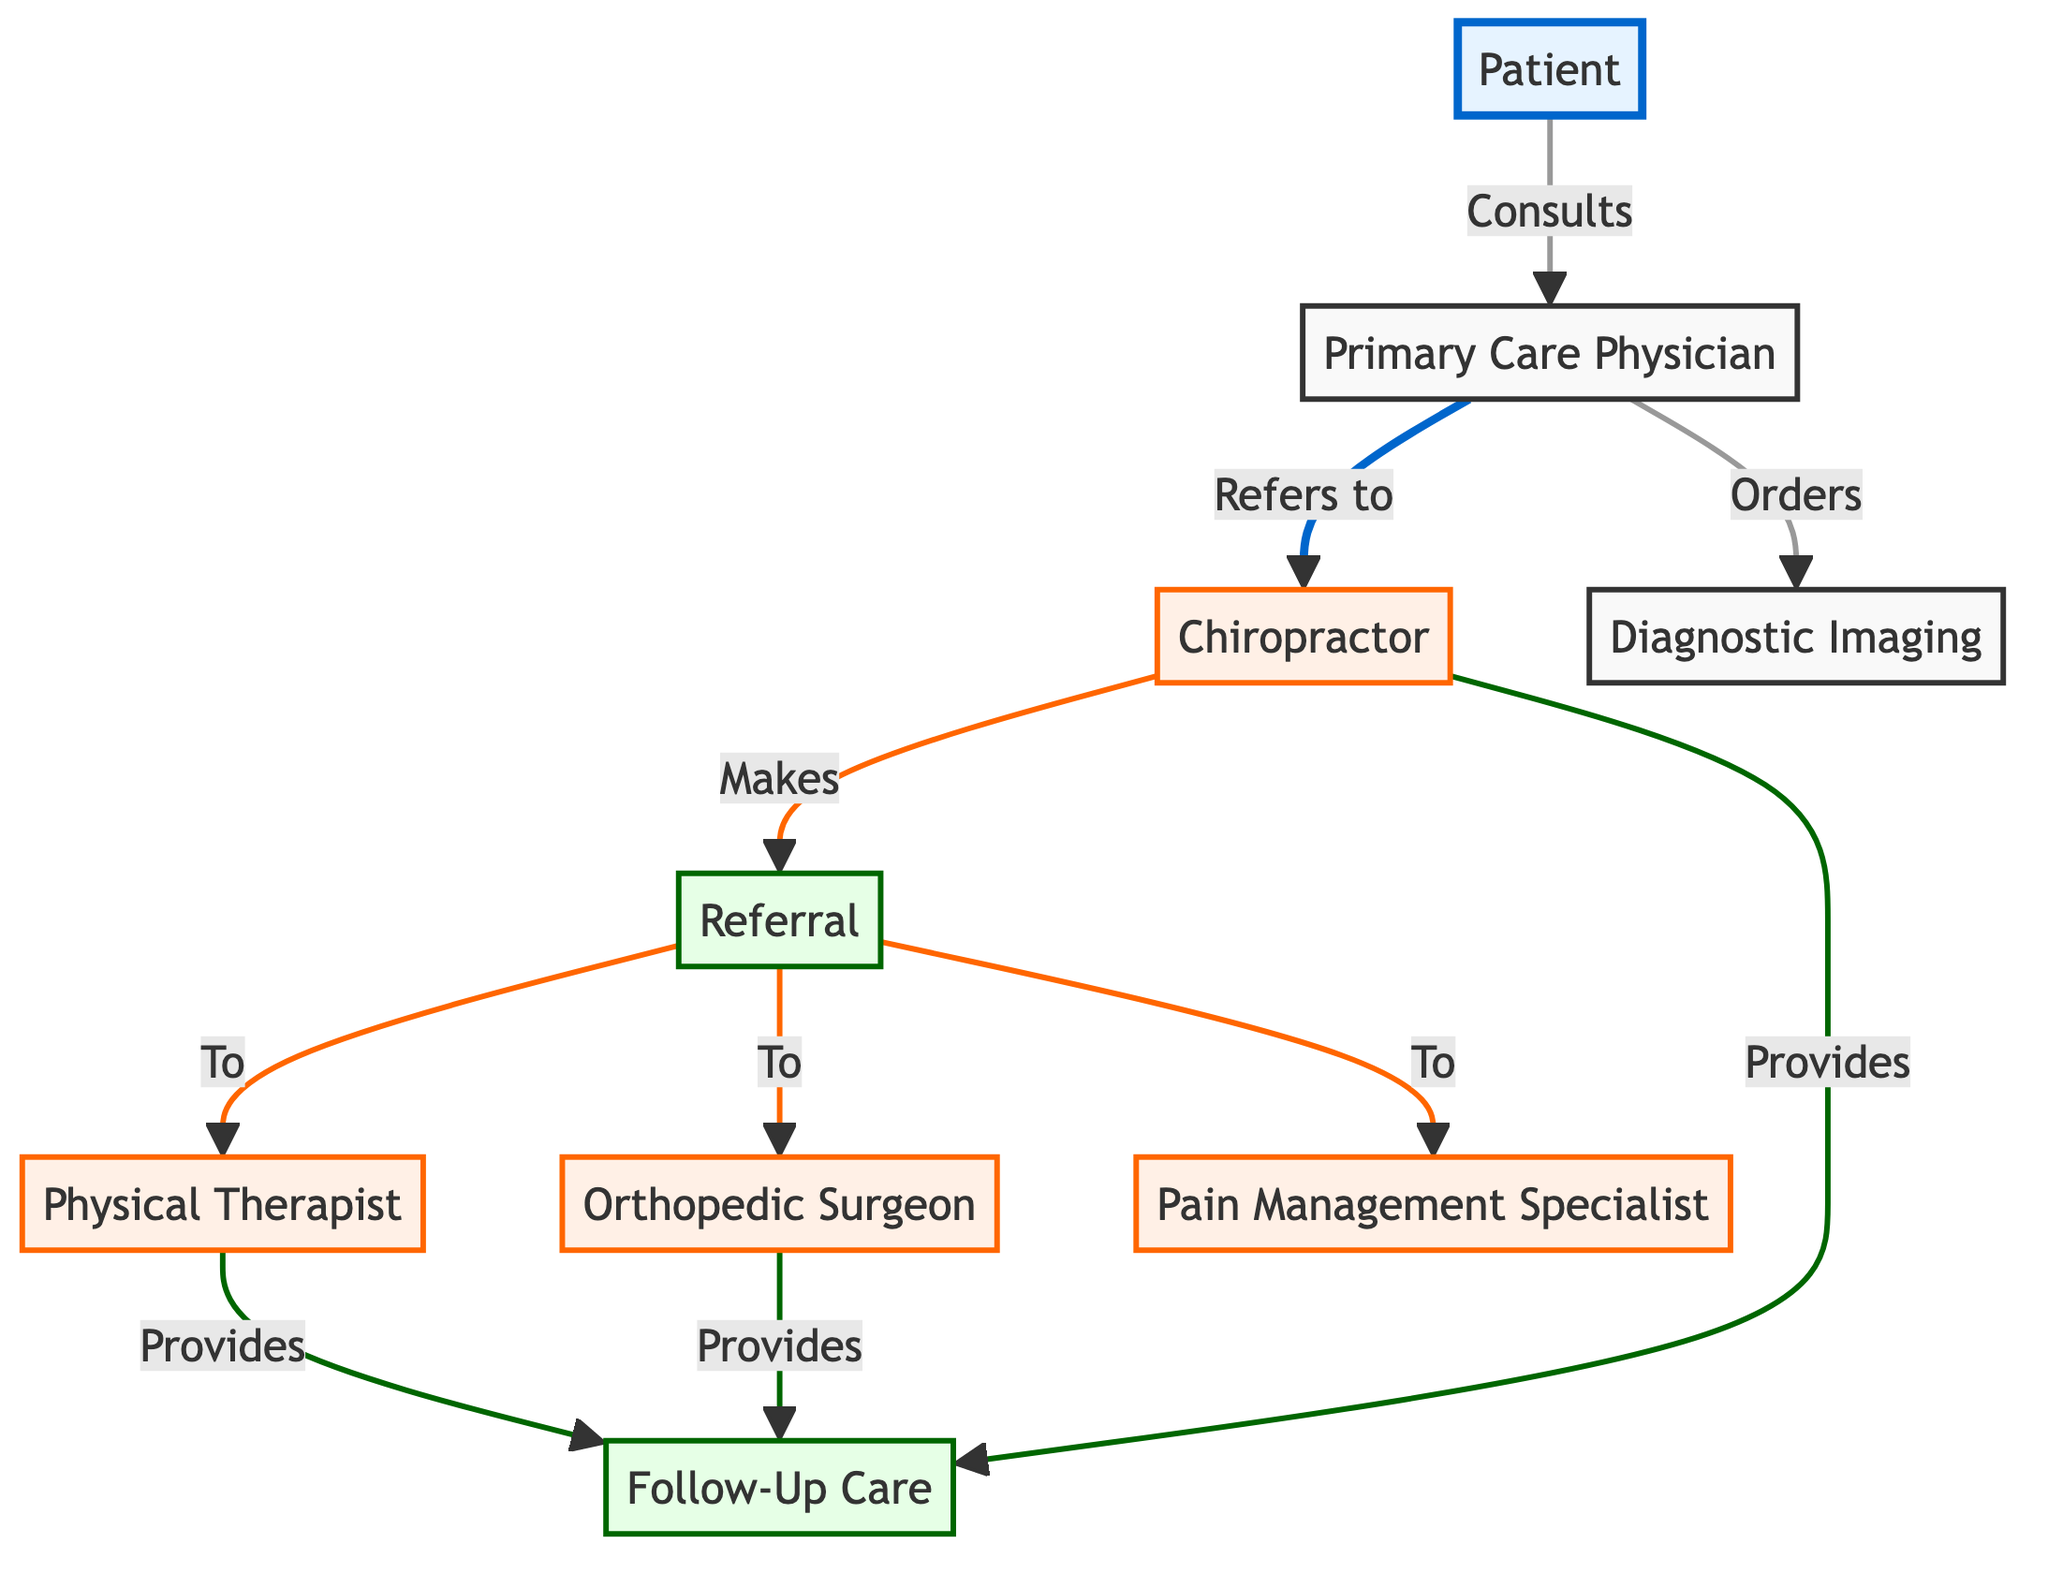What is the starting point in the referral pathway? The starting point in the referral pathway is the "Patient," who initiates the process by consulting with the "Primary Care Physician."
Answer: Patient How many specialists are directly referred to from the Chiropractor? The Chiropractor makes a referral to three specialists: "Physical Therapist," "Orthopedic Surgeon," and "Pain Management Specialist."
Answer: 3 Which node is connected to both the Primary Care Physician and the Chiropractic node? The "Chiropractor" is connected to the "Primary Care Physician" through a referral pathway, meaning that the patient is initially seen by the Primary Care Physician and potentially referred to the Chiropractor.
Answer: Chiropractor What role does the Primary Care Physician play in the diagram? The Primary Care Physician serves as the initial point of contact for the Patient and is responsible for referring them to other healthcare providers like the Chiropractor and ordering Diagnostic Imaging.
Answer: Refers How many nodes are connected to the Referral node? The Referral node connects to three nodes: "Physical Therapist," "Orthopedic Surgeon," and "Pain Management Specialist," indicating that the Chiropractor can initiate referrals to these specialists.
Answer: 3 What type of care do both the Orthopedic Surgeon and Chiropractor provide after their respective treatments? Both the Orthopedic Surgeon and Chiropractor provide "Follow-Up Care" to ensure the patient's ongoing management and recovery after treatment.
Answer: Follow-Up Care How many edges are there in the entire diagram? By counting all connections: the "Patient" has 1 edge leading to the "Primary Care Physician," the "Primary Care Physician" has 3 edges, the "Chiropractor" has 3, "Orthopedic Surgeon" has 1 edge, "Physical Therapist" has 1 edge, and "Diagnostic Imaging" has 1 edge as well, leading to a total of 10 edges in the diagram.
Answer: 10 What is the relationship between the Patient and Primary Care Physician? The relationship is that the Patient "Consults" the Primary Care Physician, indicating an initial visit for assessment and referral.
Answer: Consults 